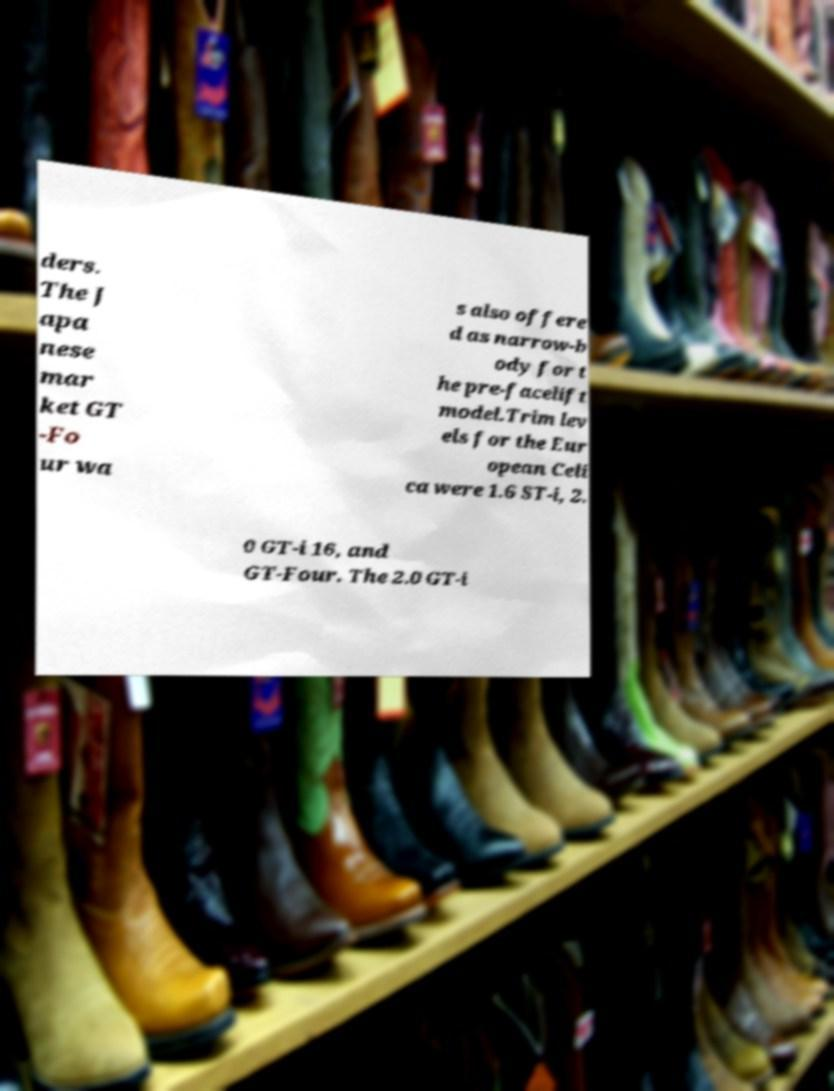What messages or text are displayed in this image? I need them in a readable, typed format. ders. The J apa nese mar ket GT -Fo ur wa s also offere d as narrow-b ody for t he pre-facelift model.Trim lev els for the Eur opean Celi ca were 1.6 ST-i, 2. 0 GT-i 16, and GT-Four. The 2.0 GT-i 